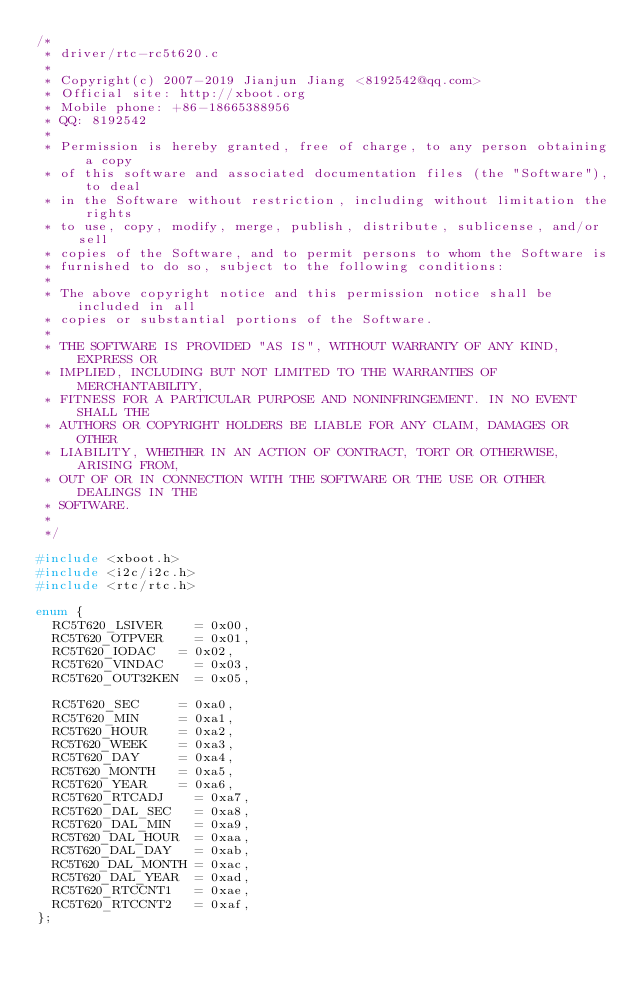Convert code to text. <code><loc_0><loc_0><loc_500><loc_500><_C_>/*
 * driver/rtc-rc5t620.c
 *
 * Copyright(c) 2007-2019 Jianjun Jiang <8192542@qq.com>
 * Official site: http://xboot.org
 * Mobile phone: +86-18665388956
 * QQ: 8192542
 *
 * Permission is hereby granted, free of charge, to any person obtaining a copy
 * of this software and associated documentation files (the "Software"), to deal
 * in the Software without restriction, including without limitation the rights
 * to use, copy, modify, merge, publish, distribute, sublicense, and/or sell
 * copies of the Software, and to permit persons to whom the Software is
 * furnished to do so, subject to the following conditions:
 *
 * The above copyright notice and this permission notice shall be included in all
 * copies or substantial portions of the Software.
 *
 * THE SOFTWARE IS PROVIDED "AS IS", WITHOUT WARRANTY OF ANY KIND, EXPRESS OR
 * IMPLIED, INCLUDING BUT NOT LIMITED TO THE WARRANTIES OF MERCHANTABILITY,
 * FITNESS FOR A PARTICULAR PURPOSE AND NONINFRINGEMENT. IN NO EVENT SHALL THE
 * AUTHORS OR COPYRIGHT HOLDERS BE LIABLE FOR ANY CLAIM, DAMAGES OR OTHER
 * LIABILITY, WHETHER IN AN ACTION OF CONTRACT, TORT OR OTHERWISE, ARISING FROM,
 * OUT OF OR IN CONNECTION WITH THE SOFTWARE OR THE USE OR OTHER DEALINGS IN THE
 * SOFTWARE.
 *
 */

#include <xboot.h>
#include <i2c/i2c.h>
#include <rtc/rtc.h>

enum {
	RC5T620_LSIVER		= 0x00,
	RC5T620_OTPVER		= 0x01,
	RC5T620_IODAC		= 0x02,
	RC5T620_VINDAC		= 0x03,
	RC5T620_OUT32KEN	= 0x05,

	RC5T620_SEC			= 0xa0,
	RC5T620_MIN			= 0xa1,
	RC5T620_HOUR		= 0xa2,
	RC5T620_WEEK		= 0xa3,
	RC5T620_DAY			= 0xa4,
	RC5T620_MONTH		= 0xa5,
	RC5T620_YEAR		= 0xa6,
	RC5T620_RTCADJ		= 0xa7,
	RC5T620_DAL_SEC		= 0xa8,
	RC5T620_DAL_MIN		= 0xa9,
	RC5T620_DAL_HOUR	= 0xaa,
	RC5T620_DAL_DAY		= 0xab,
	RC5T620_DAL_MONTH	= 0xac,
	RC5T620_DAL_YEAR	= 0xad,
	RC5T620_RTCCNT1		= 0xae,
	RC5T620_RTCCNT2		= 0xaf,
};
</code> 